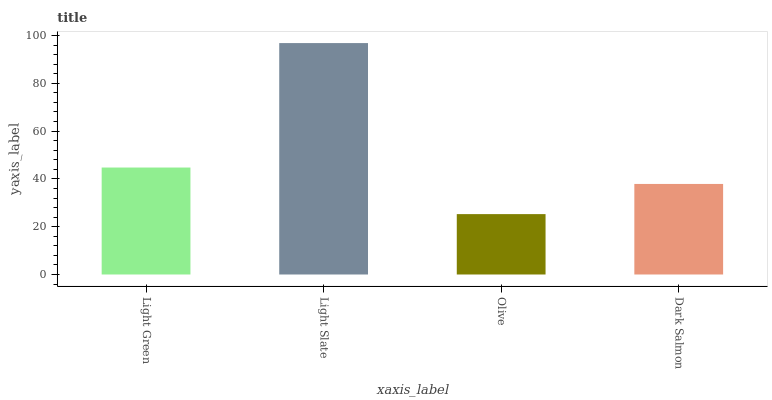Is Olive the minimum?
Answer yes or no. Yes. Is Light Slate the maximum?
Answer yes or no. Yes. Is Light Slate the minimum?
Answer yes or no. No. Is Olive the maximum?
Answer yes or no. No. Is Light Slate greater than Olive?
Answer yes or no. Yes. Is Olive less than Light Slate?
Answer yes or no. Yes. Is Olive greater than Light Slate?
Answer yes or no. No. Is Light Slate less than Olive?
Answer yes or no. No. Is Light Green the high median?
Answer yes or no. Yes. Is Dark Salmon the low median?
Answer yes or no. Yes. Is Olive the high median?
Answer yes or no. No. Is Light Slate the low median?
Answer yes or no. No. 